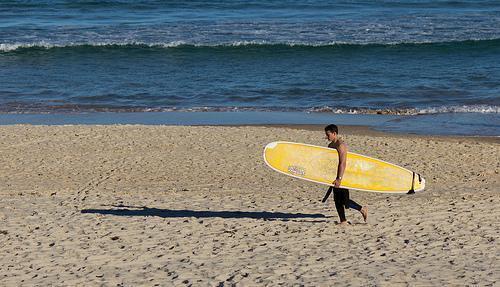How many people are shown?
Give a very brief answer. 1. 